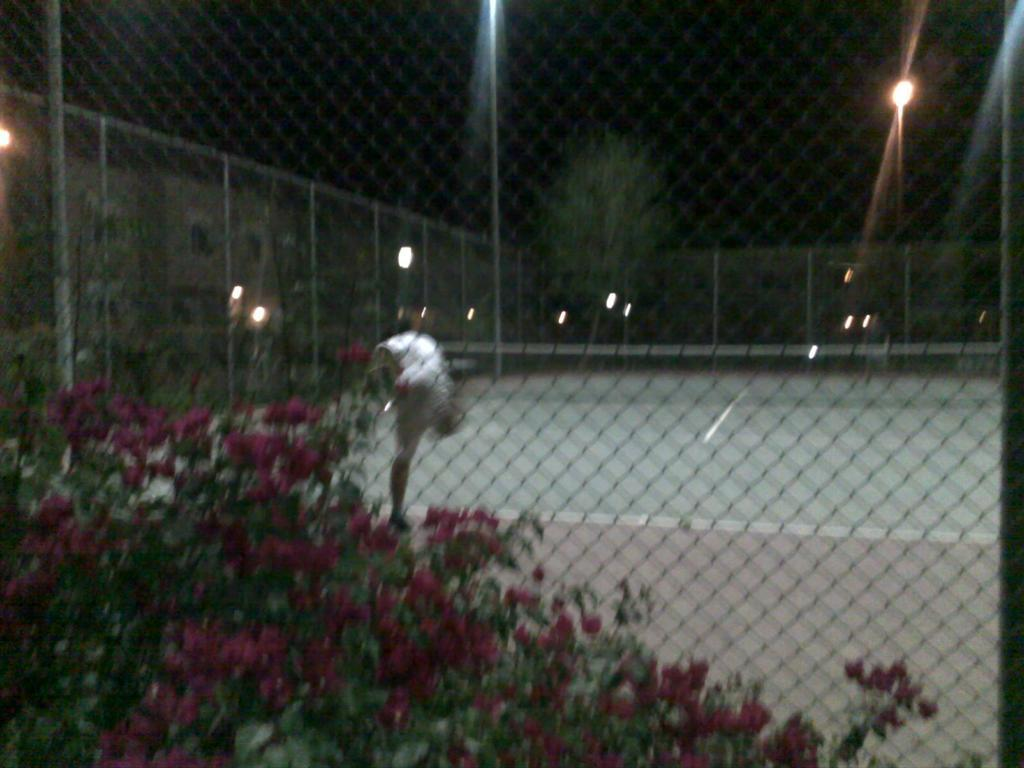What is the image, what is the person doing? There is a person playing in the image. Where is the person playing? The person is playing in a ground. What can be seen around the ground? The ground is surrounded by a fence. What type of natural elements are present in the image? There are trees, plants, and flowers in the image. What type of man-made structures can be seen in the image? There are buildings and street lights in the image. What type of verse can be heard being recited by the person in the image? There is no indication in the image that the person is reciting a verse, so it cannot be determined from the image. 